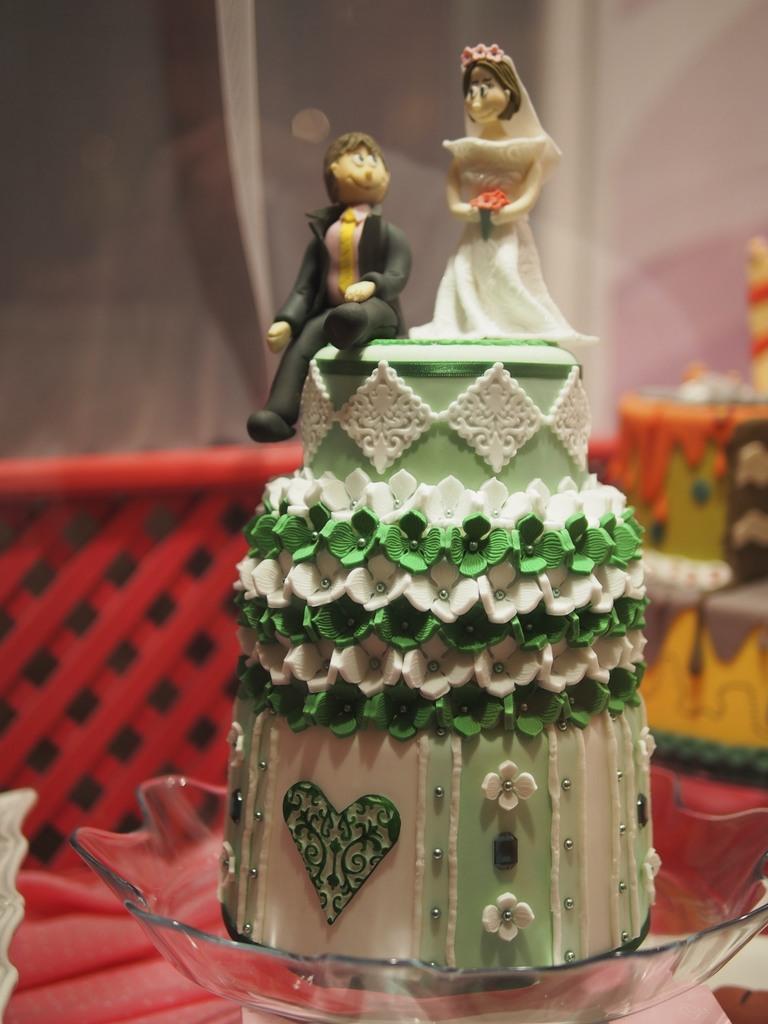Could you give a brief overview of what you see in this image? In this picture we can see a cake on glass bowl. On the cake we can see persons statue. On the background we can see a wooden fencing and tables. On the top right corner there is a wall. 